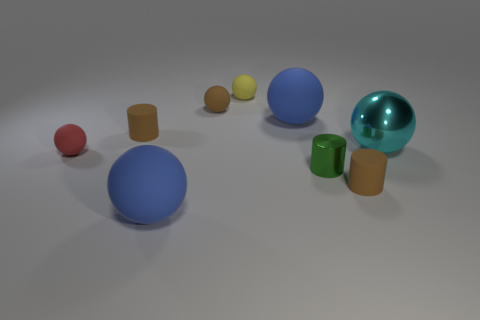Are there any small green objects that have the same shape as the big cyan thing?
Keep it short and to the point. No. Are the tiny red ball and the small brown thing that is to the left of the brown rubber ball made of the same material?
Keep it short and to the point. Yes. The shiny cylinder has what color?
Give a very brief answer. Green. How many small red objects are on the right side of the blue rubber sphere that is in front of the brown object on the left side of the tiny brown ball?
Your answer should be compact. 0. There is a red rubber thing; are there any matte spheres right of it?
Your response must be concise. Yes. How many big blue objects have the same material as the red ball?
Ensure brevity in your answer.  2. What number of objects are small yellow objects or yellow cubes?
Your answer should be compact. 1. Are there any small things?
Your answer should be very brief. Yes. There is a small brown cylinder in front of the brown rubber cylinder left of the tiny yellow rubber object left of the cyan object; what is its material?
Your answer should be very brief. Rubber. Is the number of brown balls that are behind the small yellow sphere less than the number of yellow rubber spheres?
Keep it short and to the point. Yes. 